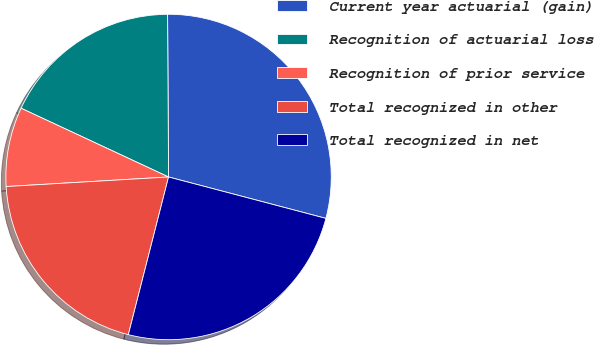Convert chart. <chart><loc_0><loc_0><loc_500><loc_500><pie_chart><fcel>Current year actuarial (gain)<fcel>Recognition of actuarial loss<fcel>Recognition of prior service<fcel>Total recognized in other<fcel>Total recognized in net<nl><fcel>29.19%<fcel>17.96%<fcel>7.88%<fcel>20.09%<fcel>24.88%<nl></chart> 